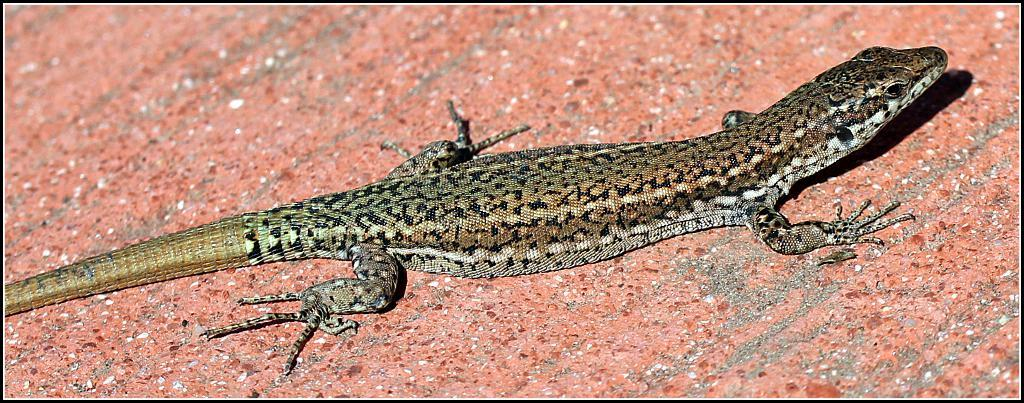What type of animal is in the image? There is a lizard in the image. Where is the lizard located? The lizard is on a surface. What type of sleet can be seen falling in the image? There is no sleet present in the image; it features a lizard on a surface. What type of picture is the lizard in the image? The image is not a picture of a picture; it is a direct representation of the lizard and its surroundings. 